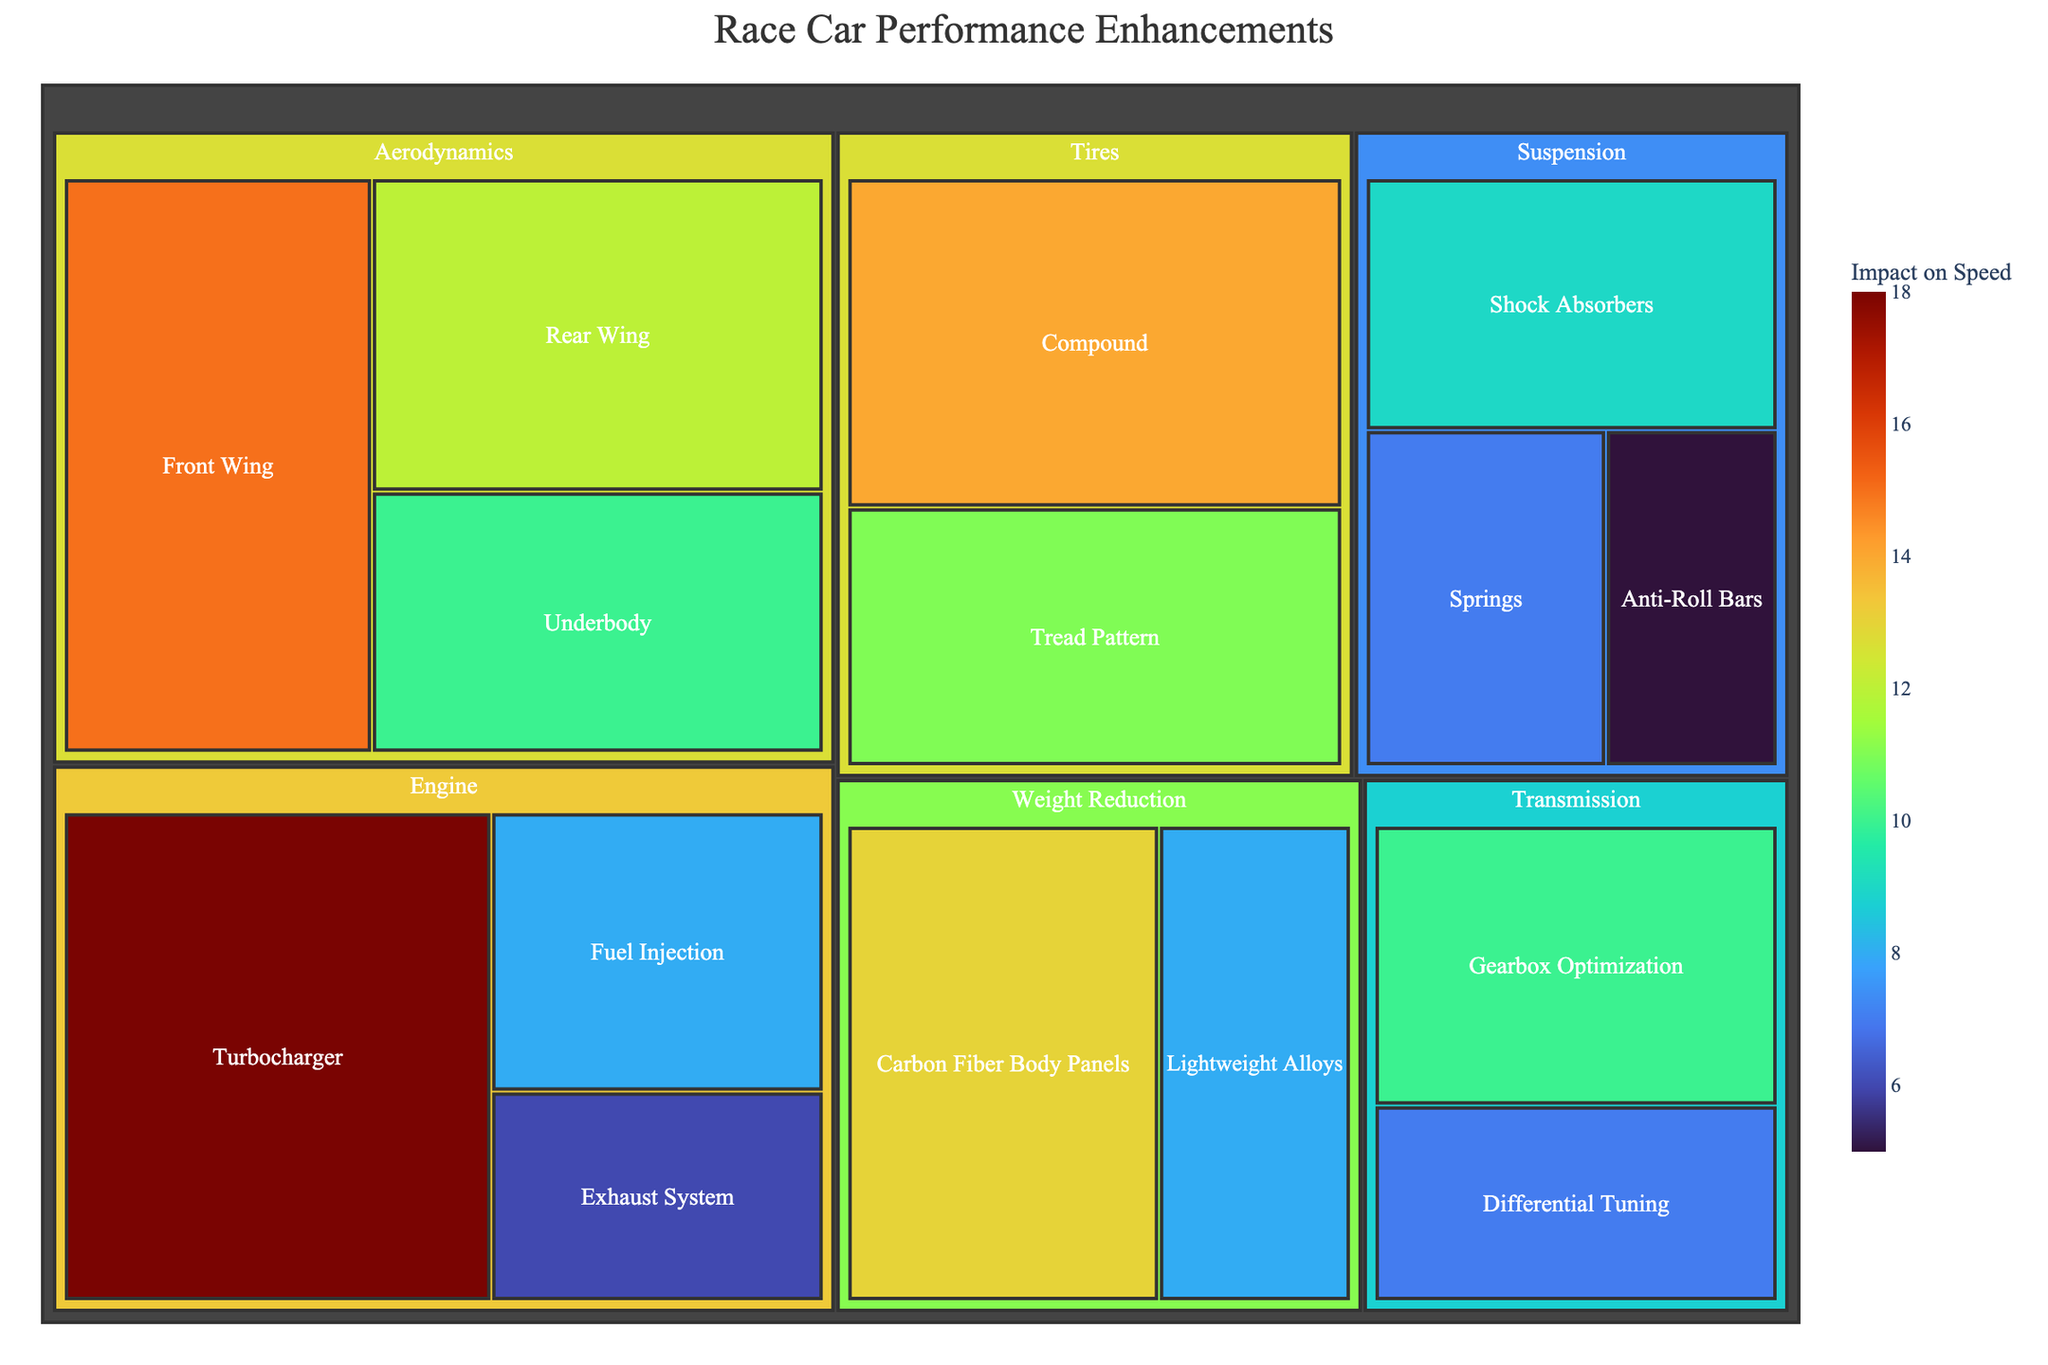Is the impact of the Front Wing higher than that of the Rear Wing? To determine this, look at the impact values for both the Front Wing and the Rear Wing. The Front Wing has an impact value of 15 while the Rear Wing has an impact value of 12.
Answer: Yes Which category has the highest individual impact on speed? Examine all categories and their subcategories for their impact values. The Turbocharger under the Engine category has the highest impact value at 18.
Answer: Engine (Turbocharger) What is the total impact of all enhancements in the Suspension category? Add together the impact values for all subcategories under Suspension: Shock Absorbers (9), Springs (7), and Anti-Roll Bars (5). The total impact is 9 + 7 + 5 = 21.
Answer: 21 How does the impact of Tires' Compound compare to Weight Reduction's Carbon Fiber Body Panels? Look at the impact values for both subcategories. Tires' Compound has an impact value of 14, while Weight Reduction's Carbon Fiber Body Panels has an impact value of 13.
Answer: Compound has a higher impact Which subcategory has the lowest impact on speed? Identify subcategories with the lowest impact value by examining all the subcategories in the figure. The lowest impact value is 5 for the Anti-Roll Bars in the Suspension category.
Answer: Anti-Roll Bars What is the total impact of all enhancements in the Tires category? Add together the impact values for all subcategories under Tires: Compound (14) and Tread Pattern (11). The total impact is 14 + 11 = 25.
Answer: 25 Is the impact of the Gearbox Optimization higher, lower, or equal to that of the Underbody? Compare the impact values for Gearbox Optimization and Underbody. The Gearbox Optimization has an impact value of 10, which is equal to the Underbody's impact value of 10.
Answer: Equal What is the average impact value for enhancements in the Aerodynamics category? Add together the impact values for all subcategories under Aerodynamics (Front Wing 15, Rear Wing 12, Underbody 10), then divide by the number of subcategories. The total is 15 + 12 + 10 = 37, so the average is 37/3 ≈ 12.33.
Answer: 12.33 How does the total impact of the Engine category compare to the total impact of the Transmission category? First, calculate the total impact for Engine: Turbocharger (18), Fuel Injection (8), and Exhaust System (6), giving 18 + 8 + 6 = 32. Then, calculate the total impact for Transmission: Gearbox Optimization (10) and Differential Tuning (7), giving 10 + 7 = 17. The Engine category has a higher total impact.
Answer: Engine has a higher total impact Which category has the most subcategories? Count the number of subcategories within each category. Aerodynamics, Engine, Suspension, and Transmission all have 3 subcategories each, while Tires and Weight Reduction have 2 subcategories each. However, Aerodynamics is the first in the dataset with the maximum range of subcategories.
Answer: Aerodynamics, Engine, Suspension, Transmission 